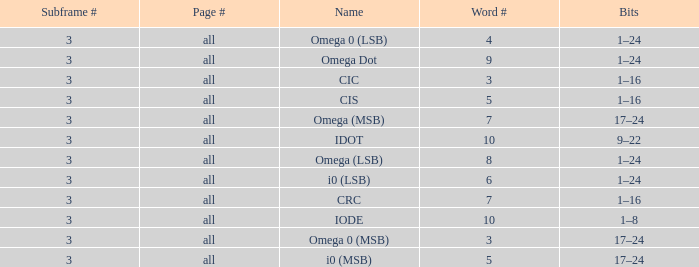What is the word count that is named omega dot? 9.0. 